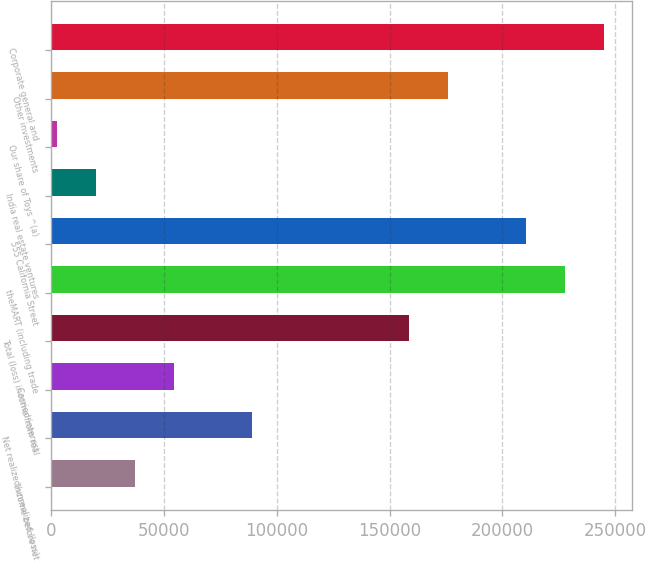<chart> <loc_0><loc_0><loc_500><loc_500><bar_chart><fcel>Income before net<fcel>Net realized/unrealized (loss)<fcel>Carried interest<fcel>Total (loss) income from real<fcel>theMART (including trade<fcel>555 California Street<fcel>India real estate ventures<fcel>Our share of Toys ^(a)<fcel>Other investments<fcel>Corporate general and<nl><fcel>37154.4<fcel>89136<fcel>54481.6<fcel>158445<fcel>227754<fcel>210426<fcel>19827.2<fcel>2500<fcel>175772<fcel>245081<nl></chart> 